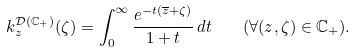<formula> <loc_0><loc_0><loc_500><loc_500>k ^ { \mathcal { D } ( \mathbb { C } _ { + } ) } _ { z } ( \zeta ) = \int _ { 0 } ^ { \infty } \frac { e ^ { - t ( \overline { z } + \zeta ) } } { 1 + t } \, d t \quad ( \forall ( z , \zeta ) \in \mathbb { C } _ { + } ) .</formula> 